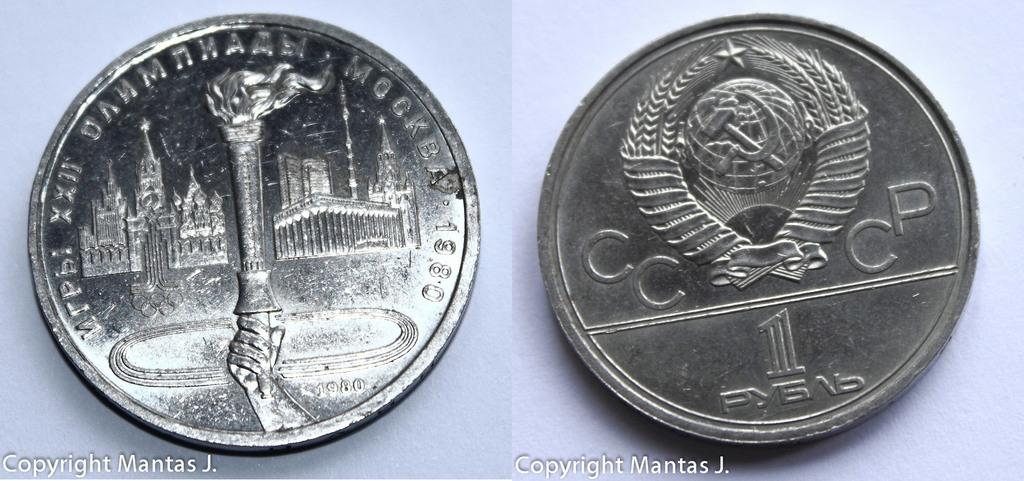<image>
Give a short and clear explanation of the subsequent image. A coin shows a torch on one side and CCCP on the other. 